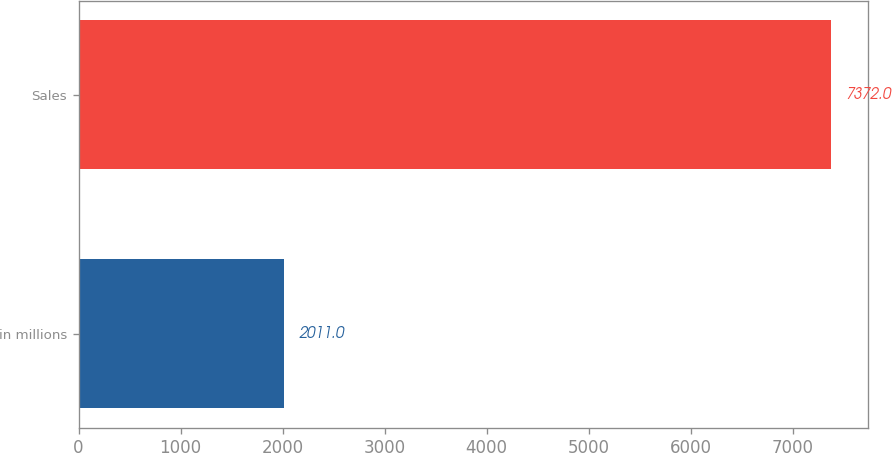Convert chart. <chart><loc_0><loc_0><loc_500><loc_500><bar_chart><fcel>in millions<fcel>Sales<nl><fcel>2011<fcel>7372<nl></chart> 